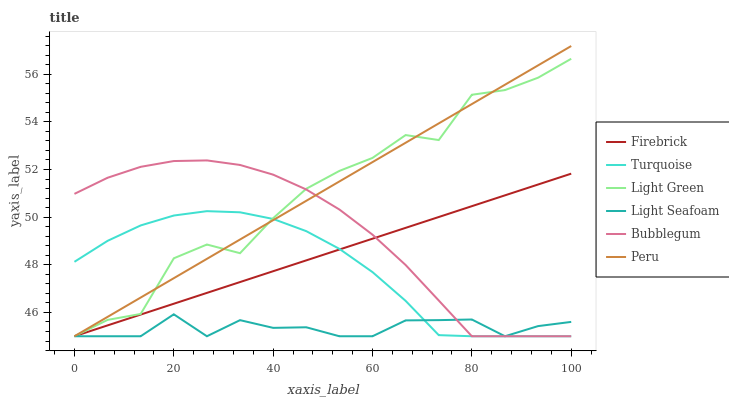Does Light Seafoam have the minimum area under the curve?
Answer yes or no. Yes. Does Light Green have the maximum area under the curve?
Answer yes or no. Yes. Does Firebrick have the minimum area under the curve?
Answer yes or no. No. Does Firebrick have the maximum area under the curve?
Answer yes or no. No. Is Peru the smoothest?
Answer yes or no. Yes. Is Light Green the roughest?
Answer yes or no. Yes. Is Firebrick the smoothest?
Answer yes or no. No. Is Firebrick the roughest?
Answer yes or no. No. Does Turquoise have the lowest value?
Answer yes or no. Yes. Does Peru have the highest value?
Answer yes or no. Yes. Does Light Green have the highest value?
Answer yes or no. No. Does Bubblegum intersect Firebrick?
Answer yes or no. Yes. Is Bubblegum less than Firebrick?
Answer yes or no. No. Is Bubblegum greater than Firebrick?
Answer yes or no. No. 